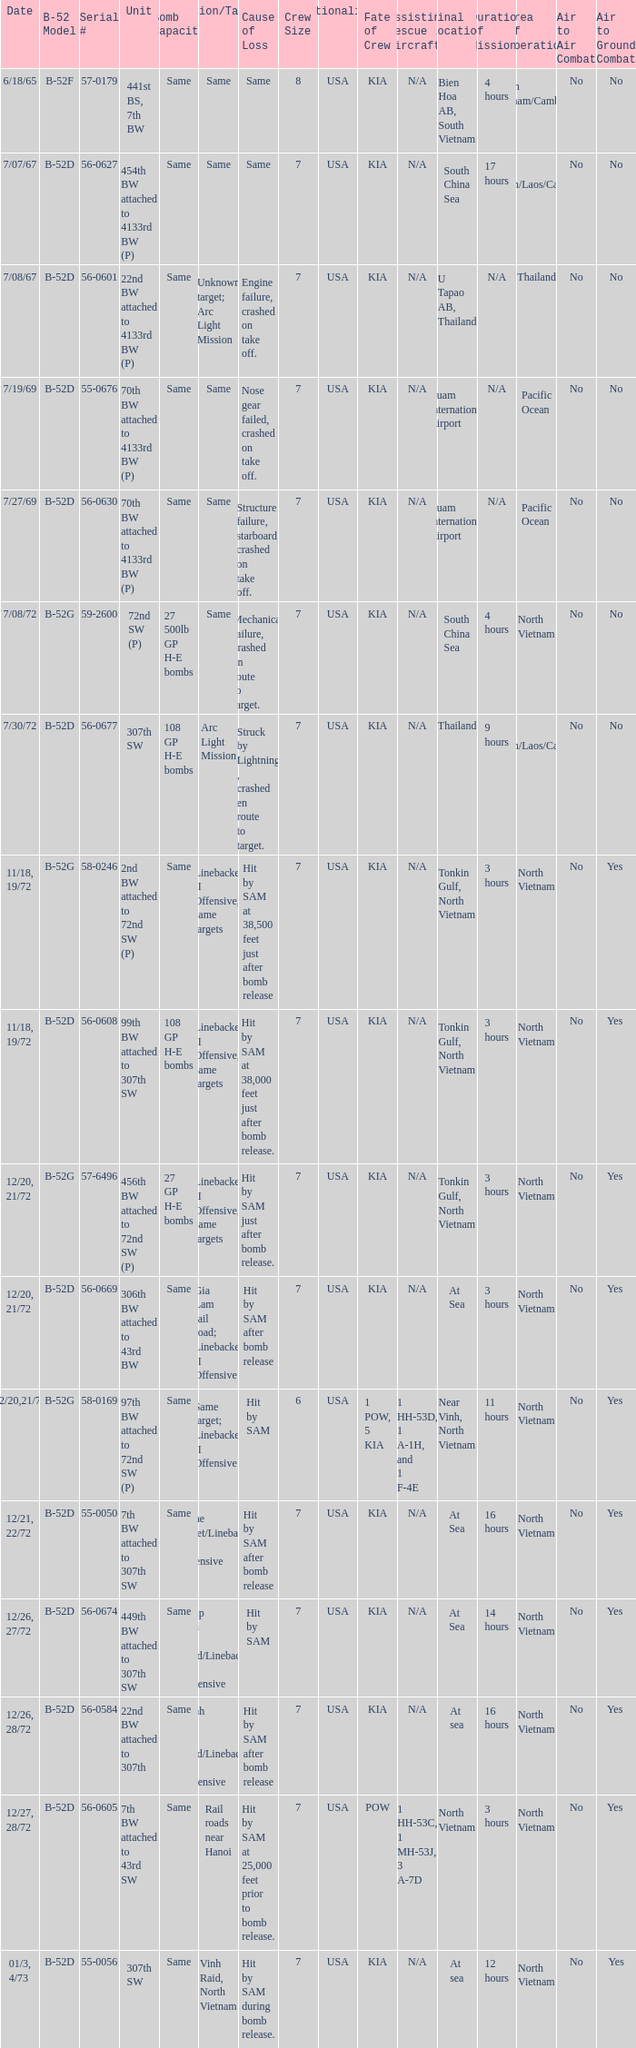When hit by sam at 38,500 feet just after bomb release was the cause of loss what is the mission/target? Linebacker II Offensive, same targets. 